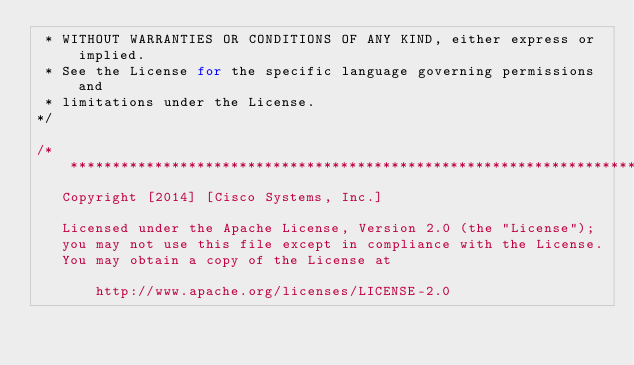<code> <loc_0><loc_0><loc_500><loc_500><_C_> * WITHOUT WARRANTIES OR CONDITIONS OF ANY KIND, either express or implied.
 * See the License for the specific language governing permissions and
 * limitations under the License.
*/

/**********************************************************************
   Copyright [2014] [Cisco Systems, Inc.]
 
   Licensed under the Apache License, Version 2.0 (the "License");
   you may not use this file except in compliance with the License.
   You may obtain a copy of the License at
 
       http://www.apache.org/licenses/LICENSE-2.0
 </code> 